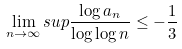<formula> <loc_0><loc_0><loc_500><loc_500>\lim _ { n \rightarrow \infty } s u p \frac { \log a _ { n } } { \log \log n } \leq - \frac { 1 } { 3 }</formula> 